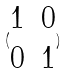Convert formula to latex. <formula><loc_0><loc_0><loc_500><loc_500>( \begin{matrix} 1 & 0 \\ 0 & 1 \end{matrix} )</formula> 